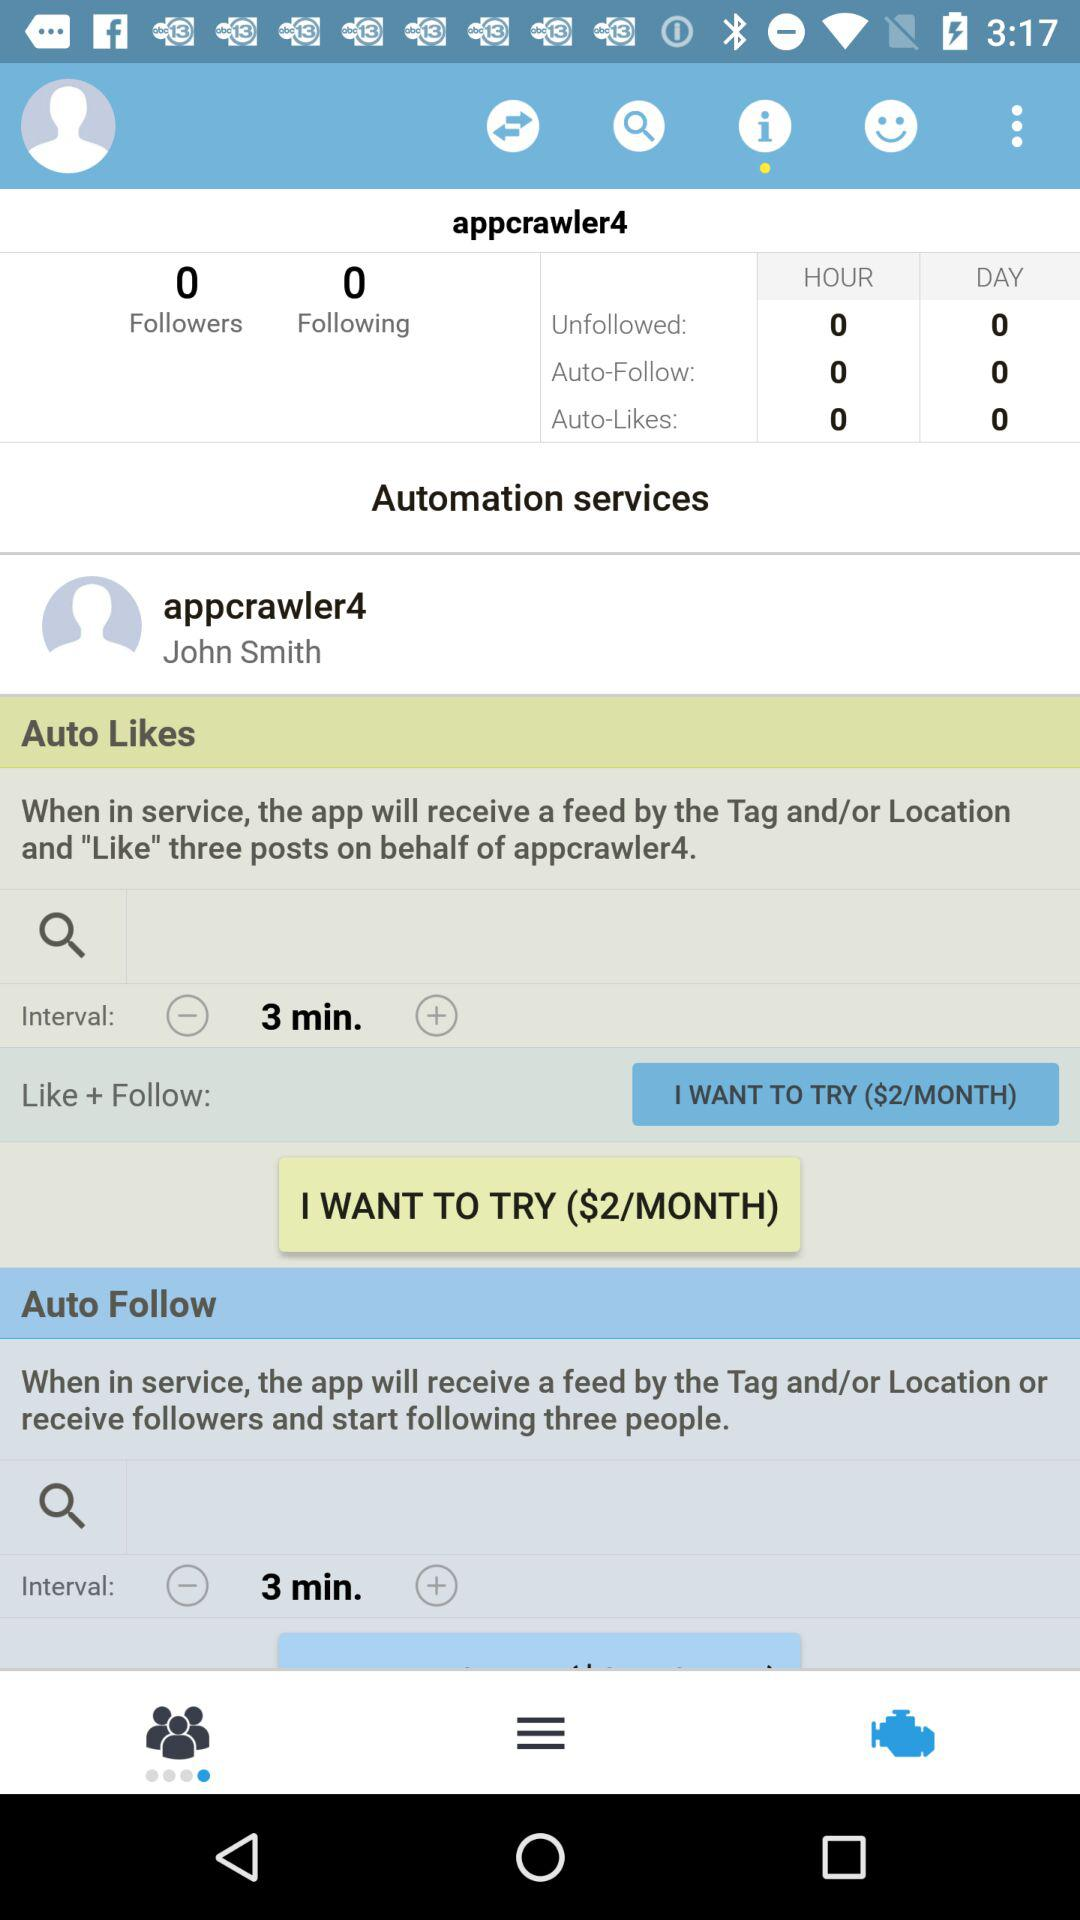What is the name of the user? The name of the user is John Smith. 